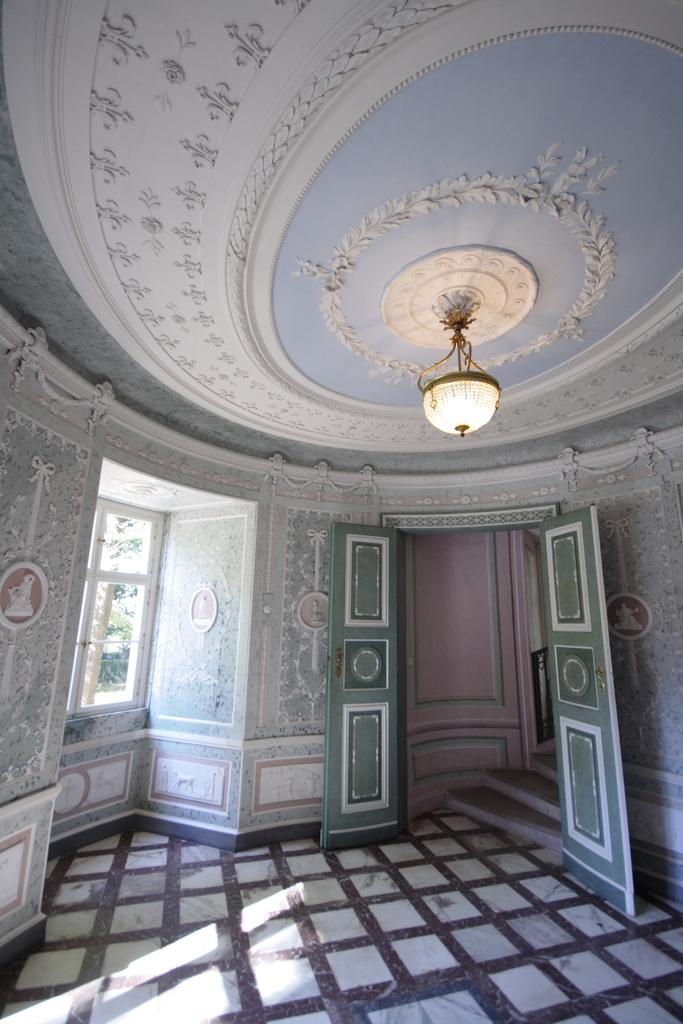What type of view is shown in the image? The image shows an inner view of a building. What can be seen hanging from the roof in the image? There is a light hanging from the roof in the image. How many doors are visible in the image? There are doors visible in the image. Can you describe the window in the image? There is a window in the image. What type of decorative elements are present on the wall and roof? Designer carvings are present on the wall and roof in the image. What type of trip can be heard happening outside the building in the image? There is no indication of a trip happening outside the building in the image, and therefore no such sound can be heard. 